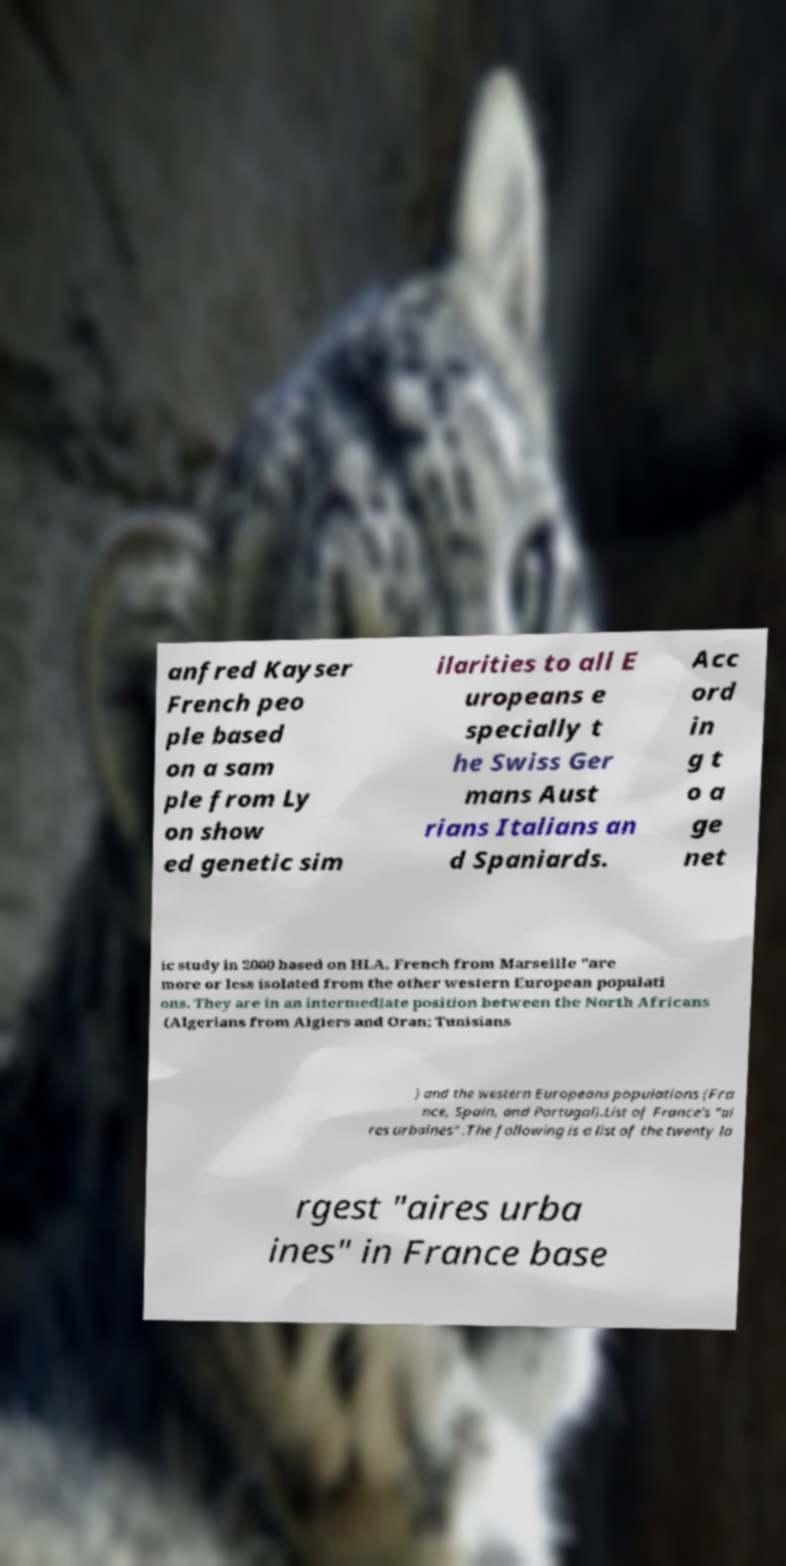What messages or text are displayed in this image? I need them in a readable, typed format. anfred Kayser French peo ple based on a sam ple from Ly on show ed genetic sim ilarities to all E uropeans e specially t he Swiss Ger mans Aust rians Italians an d Spaniards. Acc ord in g t o a ge net ic study in 2000 based on HLA, French from Marseille "are more or less isolated from the other western European populati ons. They are in an intermediate position between the North Africans (Algerians from Algiers and Oran; Tunisians ) and the western Europeans populations (Fra nce, Spain, and Portugal).List of France's "ai res urbaines" .The following is a list of the twenty la rgest "aires urba ines" in France base 